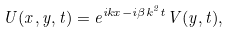Convert formula to latex. <formula><loc_0><loc_0><loc_500><loc_500>U ( x , y , t ) = e ^ { i k x - i \beta k ^ { 2 } t } V ( y , t ) ,</formula> 